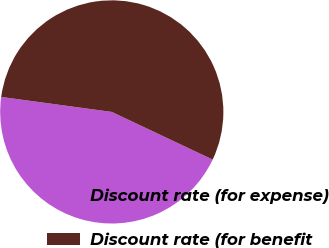Convert chart to OTSL. <chart><loc_0><loc_0><loc_500><loc_500><pie_chart><fcel>Discount rate (for expense)<fcel>Discount rate (for benefit<nl><fcel>45.12%<fcel>54.88%<nl></chart> 